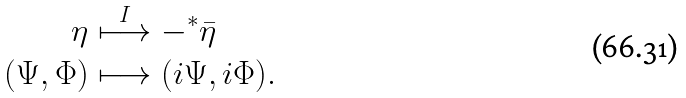<formula> <loc_0><loc_0><loc_500><loc_500>\eta & \stackrel { I } \longmapsto - ^ { * } \bar { \eta } \\ ( \Psi , \Phi ) & \longmapsto ( i \Psi , i \Phi ) .</formula> 